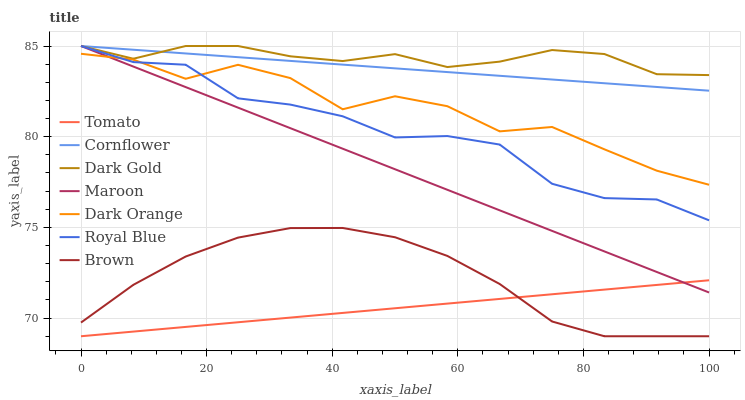Does Tomato have the minimum area under the curve?
Answer yes or no. Yes. Does Dark Gold have the maximum area under the curve?
Answer yes or no. Yes. Does Cornflower have the minimum area under the curve?
Answer yes or no. No. Does Cornflower have the maximum area under the curve?
Answer yes or no. No. Is Maroon the smoothest?
Answer yes or no. Yes. Is Dark Orange the roughest?
Answer yes or no. Yes. Is Cornflower the smoothest?
Answer yes or no. No. Is Cornflower the roughest?
Answer yes or no. No. Does Tomato have the lowest value?
Answer yes or no. Yes. Does Cornflower have the lowest value?
Answer yes or no. No. Does Royal Blue have the highest value?
Answer yes or no. Yes. Does Brown have the highest value?
Answer yes or no. No. Is Tomato less than Cornflower?
Answer yes or no. Yes. Is Royal Blue greater than Tomato?
Answer yes or no. Yes. Does Tomato intersect Maroon?
Answer yes or no. Yes. Is Tomato less than Maroon?
Answer yes or no. No. Is Tomato greater than Maroon?
Answer yes or no. No. Does Tomato intersect Cornflower?
Answer yes or no. No. 